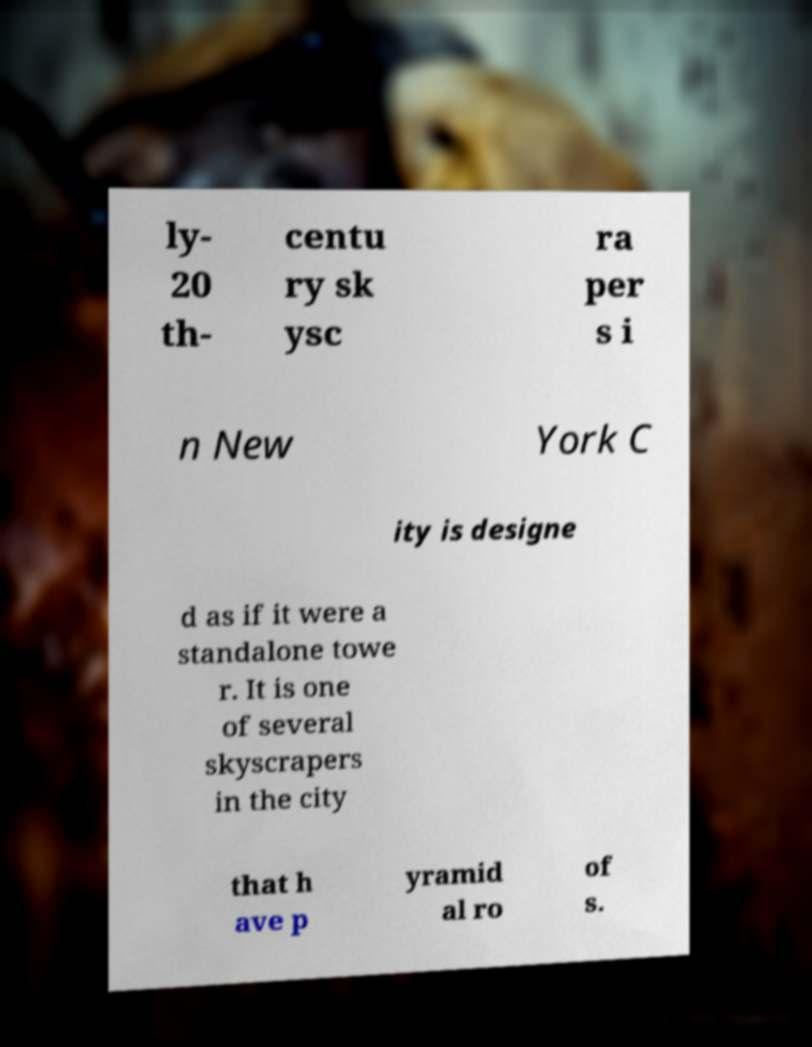For documentation purposes, I need the text within this image transcribed. Could you provide that? ly- 20 th- centu ry sk ysc ra per s i n New York C ity is designe d as if it were a standalone towe r. It is one of several skyscrapers in the city that h ave p yramid al ro of s. 